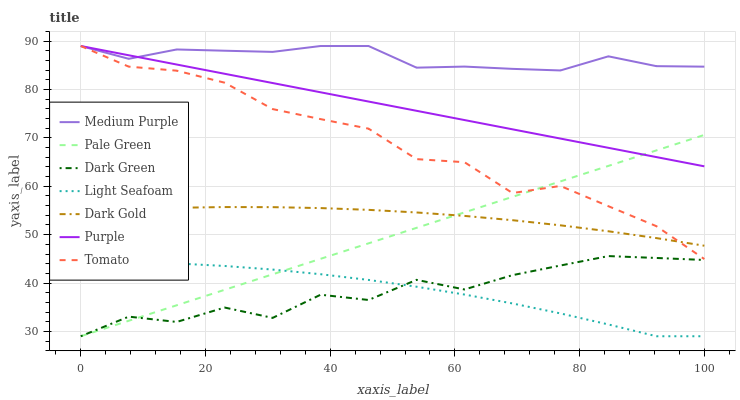Does Dark Green have the minimum area under the curve?
Answer yes or no. Yes. Does Medium Purple have the maximum area under the curve?
Answer yes or no. Yes. Does Dark Gold have the minimum area under the curve?
Answer yes or no. No. Does Dark Gold have the maximum area under the curve?
Answer yes or no. No. Is Purple the smoothest?
Answer yes or no. Yes. Is Dark Green the roughest?
Answer yes or no. Yes. Is Dark Gold the smoothest?
Answer yes or no. No. Is Dark Gold the roughest?
Answer yes or no. No. Does Pale Green have the lowest value?
Answer yes or no. Yes. Does Dark Gold have the lowest value?
Answer yes or no. No. Does Medium Purple have the highest value?
Answer yes or no. Yes. Does Dark Gold have the highest value?
Answer yes or no. No. Is Light Seafoam less than Purple?
Answer yes or no. Yes. Is Dark Gold greater than Light Seafoam?
Answer yes or no. Yes. Does Purple intersect Pale Green?
Answer yes or no. Yes. Is Purple less than Pale Green?
Answer yes or no. No. Is Purple greater than Pale Green?
Answer yes or no. No. Does Light Seafoam intersect Purple?
Answer yes or no. No. 